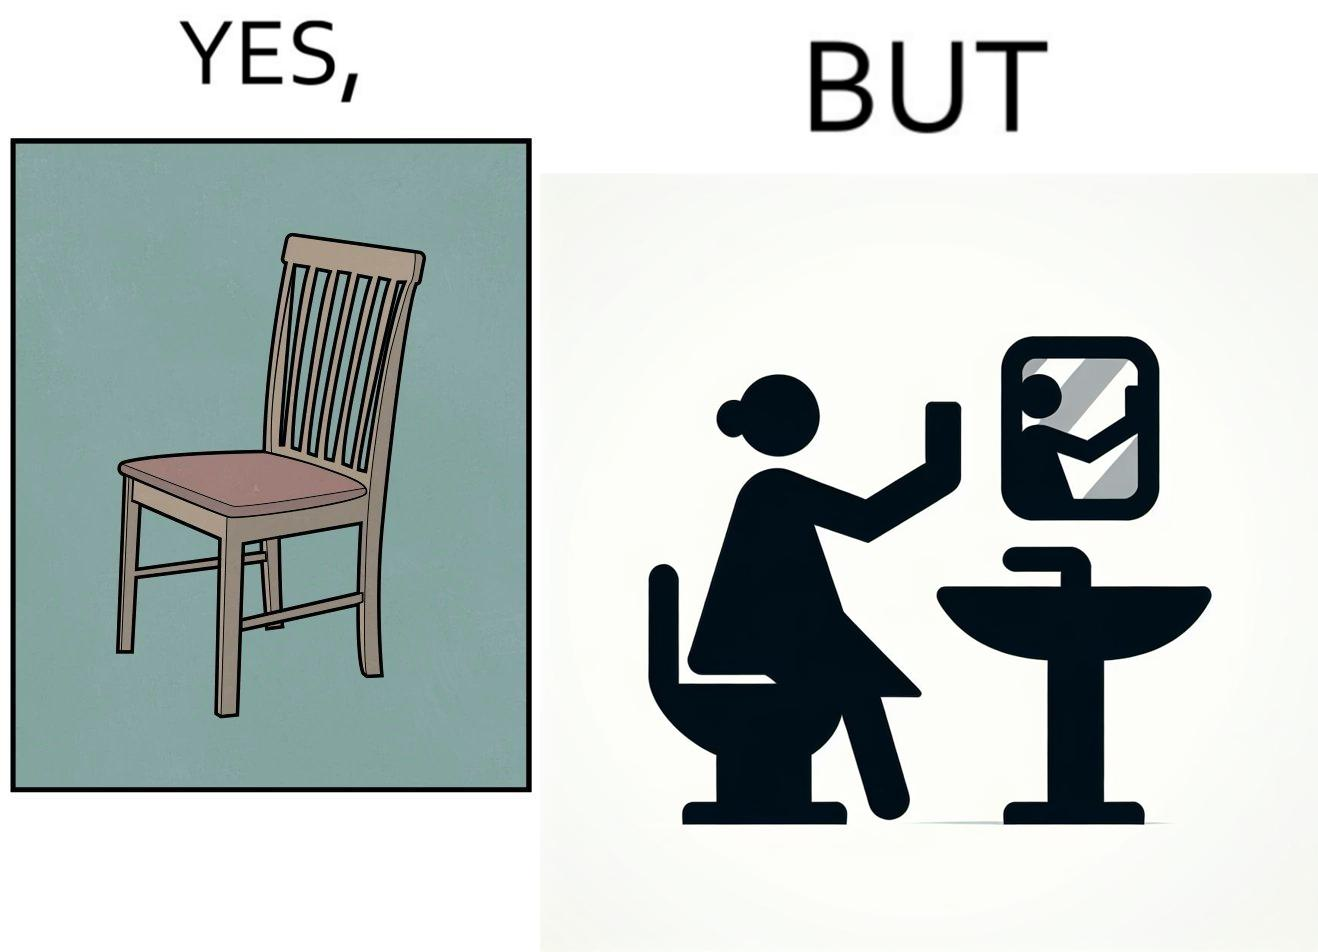Explain the humor or irony in this image. The image is ironical, as a woman is sitting by the sink taking a selfie using a mirror, while not using a chair that is actually meant for sitting. 